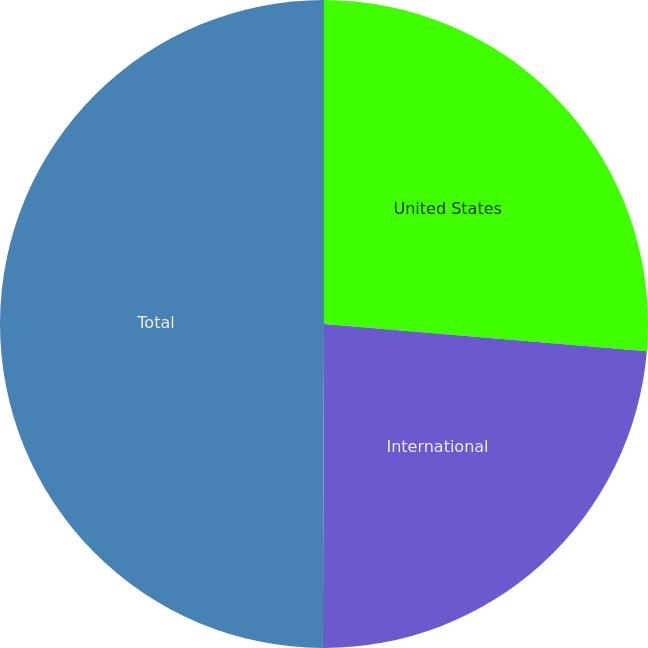Convert chart to OTSL. <chart><loc_0><loc_0><loc_500><loc_500><pie_chart><fcel>United States<fcel>International<fcel>Total<nl><fcel>26.34%<fcel>23.72%<fcel>49.95%<nl></chart> 